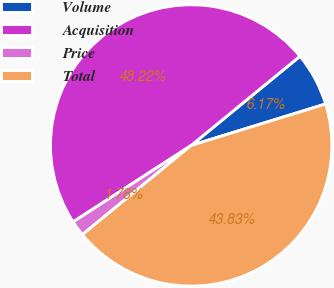Convert chart. <chart><loc_0><loc_0><loc_500><loc_500><pie_chart><fcel>Volume<fcel>Acquisition<fcel>Price<fcel>Total<nl><fcel>6.17%<fcel>48.22%<fcel>1.78%<fcel>43.83%<nl></chart> 